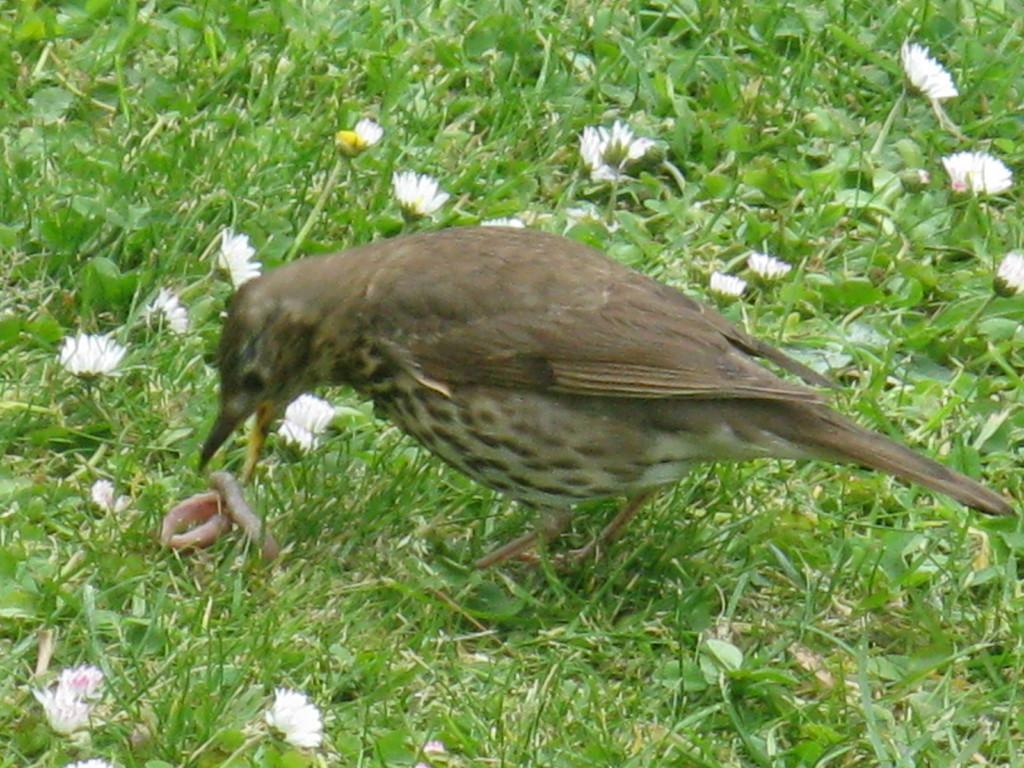How would you summarize this image in a sentence or two? In this image I can see grass and number of white colour flowers. In the centre of this image I can see a bird and an insect. 